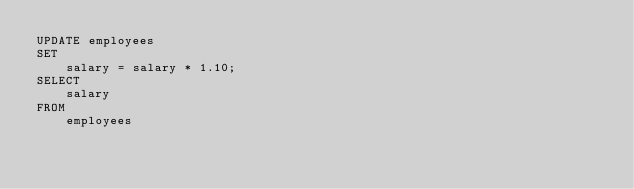<code> <loc_0><loc_0><loc_500><loc_500><_SQL_>UPDATE employees 
SET 
    salary = salary * 1.10;
SELECT 
    salary
FROM
    employees</code> 